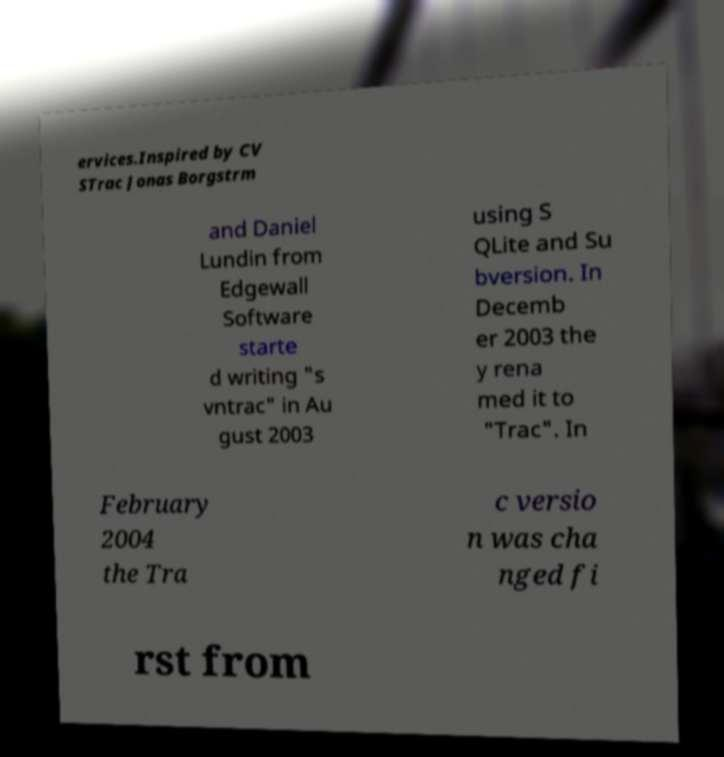Please read and relay the text visible in this image. What does it say? ervices.Inspired by CV STrac Jonas Borgstrm and Daniel Lundin from Edgewall Software starte d writing "s vntrac" in Au gust 2003 using S QLite and Su bversion. In Decemb er 2003 the y rena med it to "Trac". In February 2004 the Tra c versio n was cha nged fi rst from 